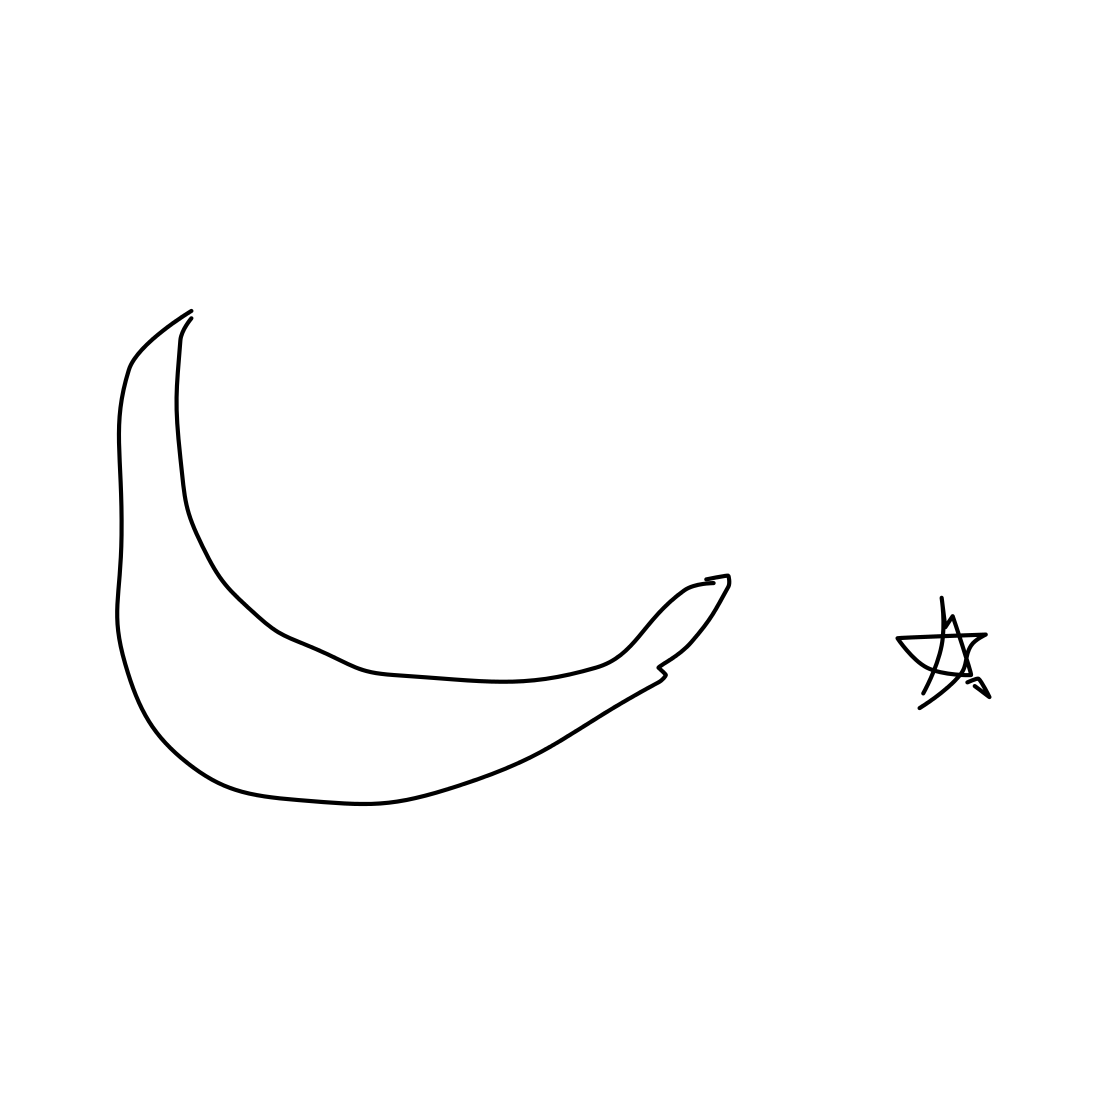What might the small star next to the banana signify in this sketch? The small star next to the banana might represent a contrast or highlight a particular quality of the banana, perhaps suggesting it is 'stellar' in its nutritional benefits or 'out of this world' in taste. It could also indicate the artist's playful or creative approach to depicting everyday objects with a touch of imagination or fantasy. 